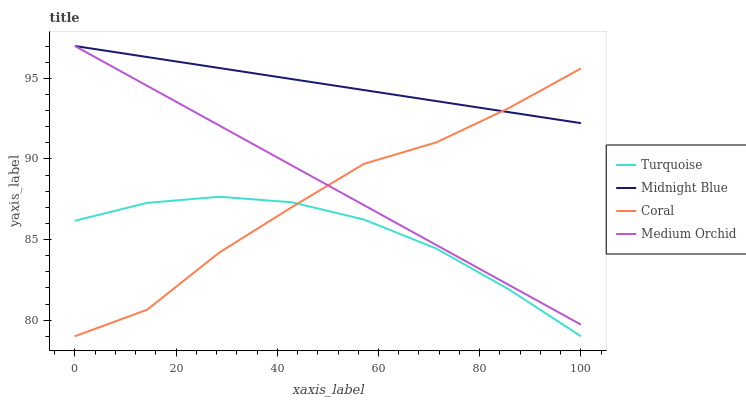Does Medium Orchid have the minimum area under the curve?
Answer yes or no. No. Does Medium Orchid have the maximum area under the curve?
Answer yes or no. No. Is Turquoise the smoothest?
Answer yes or no. No. Is Turquoise the roughest?
Answer yes or no. No. Does Medium Orchid have the lowest value?
Answer yes or no. No. Does Turquoise have the highest value?
Answer yes or no. No. Is Turquoise less than Medium Orchid?
Answer yes or no. Yes. Is Medium Orchid greater than Turquoise?
Answer yes or no. Yes. Does Turquoise intersect Medium Orchid?
Answer yes or no. No. 